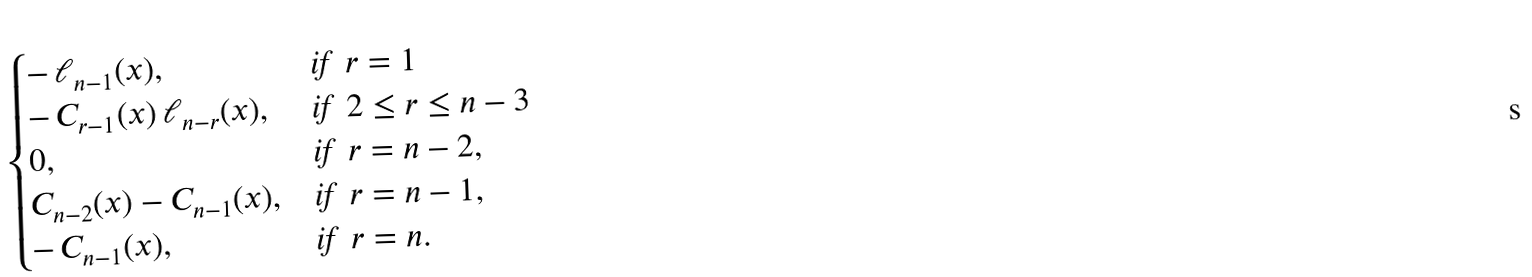<formula> <loc_0><loc_0><loc_500><loc_500>\begin{cases} - \, \ell _ { n - 1 } ( x ) , & \text {if \ $r = 1$} \\ - \, C _ { r - 1 } ( x ) \, \ell _ { n - r } ( x ) , & \text {if \ $2 \leq r \leq n-3$} \\ 0 , & \text {if \ $r = n-2$} , \\ C _ { n - 2 } ( x ) - C _ { n - 1 } ( x ) , & \text {if \ $r = n-1$} , \\ - \, C _ { n - 1 } ( x ) , & \text {if \ $r = n$} . \end{cases}</formula> 